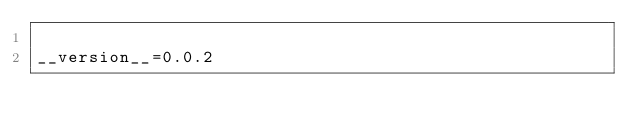Convert code to text. <code><loc_0><loc_0><loc_500><loc_500><_Python_>
__version__=0.0.2
</code> 